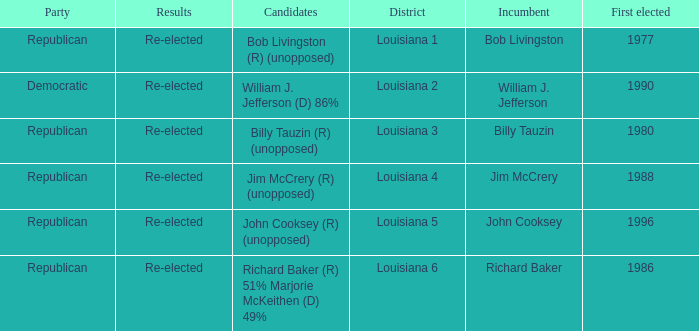What were the outcomes for the current officeholder jim mccrery? Re-elected. 